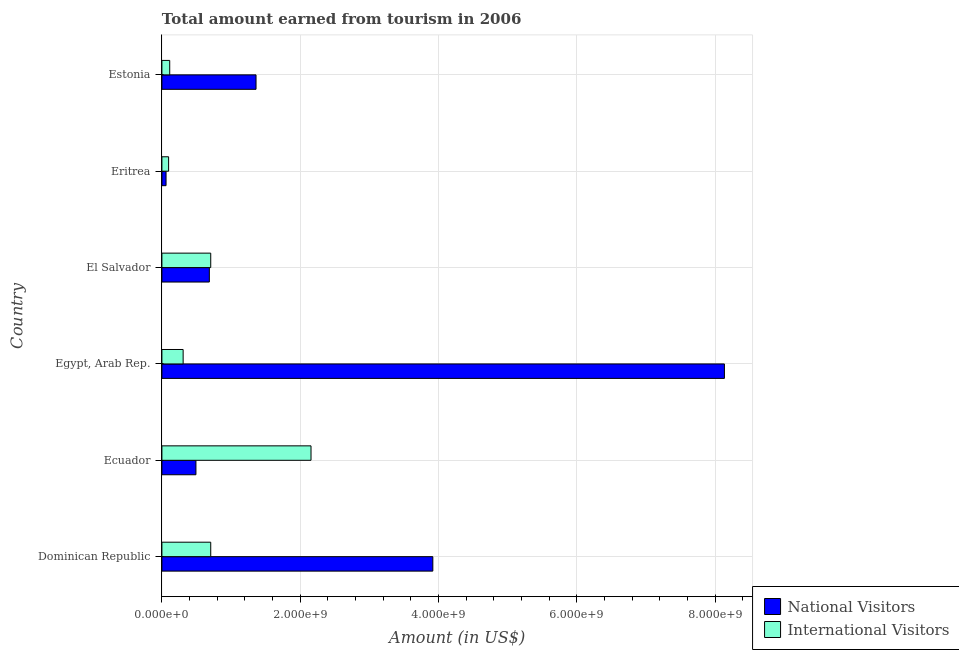Are the number of bars on each tick of the Y-axis equal?
Offer a very short reply. Yes. How many bars are there on the 3rd tick from the top?
Offer a very short reply. 2. What is the label of the 5th group of bars from the top?
Offer a very short reply. Ecuador. In how many cases, is the number of bars for a given country not equal to the number of legend labels?
Give a very brief answer. 0. What is the amount earned from international visitors in Ecuador?
Make the answer very short. 2.16e+09. Across all countries, what is the maximum amount earned from international visitors?
Your answer should be compact. 2.16e+09. Across all countries, what is the minimum amount earned from international visitors?
Offer a very short reply. 9.70e+07. In which country was the amount earned from international visitors maximum?
Give a very brief answer. Ecuador. In which country was the amount earned from national visitors minimum?
Your answer should be very brief. Eritrea. What is the total amount earned from international visitors in the graph?
Your answer should be very brief. 4.08e+09. What is the difference between the amount earned from international visitors in Ecuador and that in Egypt, Arab Rep.?
Provide a succinct answer. 1.85e+09. What is the difference between the amount earned from international visitors in Estonia and the amount earned from national visitors in El Salvador?
Keep it short and to the point. -5.73e+08. What is the average amount earned from international visitors per country?
Offer a very short reply. 6.81e+08. What is the difference between the amount earned from national visitors and amount earned from international visitors in El Salvador?
Your response must be concise. -2.00e+07. What is the ratio of the amount earned from national visitors in Eritrea to that in Estonia?
Your answer should be very brief. 0.04. Is the amount earned from international visitors in Dominican Republic less than that in Eritrea?
Provide a succinct answer. No. Is the difference between the amount earned from national visitors in Dominican Republic and Eritrea greater than the difference between the amount earned from international visitors in Dominican Republic and Eritrea?
Your answer should be very brief. Yes. What is the difference between the highest and the second highest amount earned from international visitors?
Provide a succinct answer. 1.45e+09. What is the difference between the highest and the lowest amount earned from national visitors?
Provide a succinct answer. 8.07e+09. In how many countries, is the amount earned from international visitors greater than the average amount earned from international visitors taken over all countries?
Keep it short and to the point. 3. Is the sum of the amount earned from national visitors in Egypt, Arab Rep. and El Salvador greater than the maximum amount earned from international visitors across all countries?
Offer a terse response. Yes. What does the 2nd bar from the top in Estonia represents?
Your response must be concise. National Visitors. What does the 2nd bar from the bottom in Eritrea represents?
Your response must be concise. International Visitors. Are all the bars in the graph horizontal?
Make the answer very short. Yes. What is the difference between two consecutive major ticks on the X-axis?
Provide a succinct answer. 2.00e+09. Are the values on the major ticks of X-axis written in scientific E-notation?
Make the answer very short. Yes. Where does the legend appear in the graph?
Keep it short and to the point. Bottom right. How are the legend labels stacked?
Your response must be concise. Vertical. What is the title of the graph?
Your answer should be very brief. Total amount earned from tourism in 2006. What is the label or title of the X-axis?
Provide a short and direct response. Amount (in US$). What is the label or title of the Y-axis?
Your answer should be very brief. Country. What is the Amount (in US$) in National Visitors in Dominican Republic?
Provide a succinct answer. 3.92e+09. What is the Amount (in US$) of International Visitors in Dominican Republic?
Provide a short and direct response. 7.06e+08. What is the Amount (in US$) in National Visitors in Ecuador?
Your answer should be compact. 4.92e+08. What is the Amount (in US$) in International Visitors in Ecuador?
Provide a succinct answer. 2.16e+09. What is the Amount (in US$) of National Visitors in Egypt, Arab Rep.?
Your response must be concise. 8.13e+09. What is the Amount (in US$) in International Visitors in Egypt, Arab Rep.?
Ensure brevity in your answer.  3.07e+08. What is the Amount (in US$) of National Visitors in El Salvador?
Offer a terse response. 6.86e+08. What is the Amount (in US$) in International Visitors in El Salvador?
Make the answer very short. 7.06e+08. What is the Amount (in US$) of National Visitors in Eritrea?
Your response must be concise. 6.00e+07. What is the Amount (in US$) of International Visitors in Eritrea?
Keep it short and to the point. 9.70e+07. What is the Amount (in US$) in National Visitors in Estonia?
Give a very brief answer. 1.36e+09. What is the Amount (in US$) of International Visitors in Estonia?
Your answer should be very brief. 1.13e+08. Across all countries, what is the maximum Amount (in US$) in National Visitors?
Provide a short and direct response. 8.13e+09. Across all countries, what is the maximum Amount (in US$) of International Visitors?
Your answer should be very brief. 2.16e+09. Across all countries, what is the minimum Amount (in US$) in National Visitors?
Provide a succinct answer. 6.00e+07. Across all countries, what is the minimum Amount (in US$) in International Visitors?
Your answer should be compact. 9.70e+07. What is the total Amount (in US$) of National Visitors in the graph?
Provide a short and direct response. 1.46e+1. What is the total Amount (in US$) of International Visitors in the graph?
Make the answer very short. 4.08e+09. What is the difference between the Amount (in US$) of National Visitors in Dominican Republic and that in Ecuador?
Your answer should be compact. 3.42e+09. What is the difference between the Amount (in US$) in International Visitors in Dominican Republic and that in Ecuador?
Your answer should be very brief. -1.45e+09. What is the difference between the Amount (in US$) of National Visitors in Dominican Republic and that in Egypt, Arab Rep.?
Keep it short and to the point. -4.22e+09. What is the difference between the Amount (in US$) of International Visitors in Dominican Republic and that in Egypt, Arab Rep.?
Your answer should be compact. 3.99e+08. What is the difference between the Amount (in US$) in National Visitors in Dominican Republic and that in El Salvador?
Give a very brief answer. 3.23e+09. What is the difference between the Amount (in US$) of International Visitors in Dominican Republic and that in El Salvador?
Offer a very short reply. 0. What is the difference between the Amount (in US$) of National Visitors in Dominican Republic and that in Eritrea?
Your answer should be compact. 3.86e+09. What is the difference between the Amount (in US$) in International Visitors in Dominican Republic and that in Eritrea?
Your response must be concise. 6.09e+08. What is the difference between the Amount (in US$) of National Visitors in Dominican Republic and that in Estonia?
Your answer should be compact. 2.56e+09. What is the difference between the Amount (in US$) in International Visitors in Dominican Republic and that in Estonia?
Make the answer very short. 5.93e+08. What is the difference between the Amount (in US$) of National Visitors in Ecuador and that in Egypt, Arab Rep.?
Keep it short and to the point. -7.64e+09. What is the difference between the Amount (in US$) in International Visitors in Ecuador and that in Egypt, Arab Rep.?
Your answer should be compact. 1.85e+09. What is the difference between the Amount (in US$) in National Visitors in Ecuador and that in El Salvador?
Give a very brief answer. -1.94e+08. What is the difference between the Amount (in US$) in International Visitors in Ecuador and that in El Salvador?
Offer a terse response. 1.45e+09. What is the difference between the Amount (in US$) of National Visitors in Ecuador and that in Eritrea?
Provide a succinct answer. 4.32e+08. What is the difference between the Amount (in US$) of International Visitors in Ecuador and that in Eritrea?
Offer a terse response. 2.06e+09. What is the difference between the Amount (in US$) in National Visitors in Ecuador and that in Estonia?
Your answer should be very brief. -8.69e+08. What is the difference between the Amount (in US$) of International Visitors in Ecuador and that in Estonia?
Offer a terse response. 2.04e+09. What is the difference between the Amount (in US$) in National Visitors in Egypt, Arab Rep. and that in El Salvador?
Provide a succinct answer. 7.45e+09. What is the difference between the Amount (in US$) of International Visitors in Egypt, Arab Rep. and that in El Salvador?
Ensure brevity in your answer.  -3.99e+08. What is the difference between the Amount (in US$) in National Visitors in Egypt, Arab Rep. and that in Eritrea?
Your answer should be very brief. 8.07e+09. What is the difference between the Amount (in US$) of International Visitors in Egypt, Arab Rep. and that in Eritrea?
Your answer should be very brief. 2.10e+08. What is the difference between the Amount (in US$) of National Visitors in Egypt, Arab Rep. and that in Estonia?
Ensure brevity in your answer.  6.77e+09. What is the difference between the Amount (in US$) in International Visitors in Egypt, Arab Rep. and that in Estonia?
Offer a terse response. 1.94e+08. What is the difference between the Amount (in US$) in National Visitors in El Salvador and that in Eritrea?
Keep it short and to the point. 6.26e+08. What is the difference between the Amount (in US$) of International Visitors in El Salvador and that in Eritrea?
Ensure brevity in your answer.  6.09e+08. What is the difference between the Amount (in US$) of National Visitors in El Salvador and that in Estonia?
Keep it short and to the point. -6.75e+08. What is the difference between the Amount (in US$) of International Visitors in El Salvador and that in Estonia?
Your answer should be very brief. 5.93e+08. What is the difference between the Amount (in US$) in National Visitors in Eritrea and that in Estonia?
Provide a succinct answer. -1.30e+09. What is the difference between the Amount (in US$) in International Visitors in Eritrea and that in Estonia?
Provide a succinct answer. -1.60e+07. What is the difference between the Amount (in US$) of National Visitors in Dominican Republic and the Amount (in US$) of International Visitors in Ecuador?
Offer a terse response. 1.76e+09. What is the difference between the Amount (in US$) in National Visitors in Dominican Republic and the Amount (in US$) in International Visitors in Egypt, Arab Rep.?
Your answer should be compact. 3.61e+09. What is the difference between the Amount (in US$) of National Visitors in Dominican Republic and the Amount (in US$) of International Visitors in El Salvador?
Offer a very short reply. 3.21e+09. What is the difference between the Amount (in US$) of National Visitors in Dominican Republic and the Amount (in US$) of International Visitors in Eritrea?
Make the answer very short. 3.82e+09. What is the difference between the Amount (in US$) of National Visitors in Dominican Republic and the Amount (in US$) of International Visitors in Estonia?
Make the answer very short. 3.80e+09. What is the difference between the Amount (in US$) in National Visitors in Ecuador and the Amount (in US$) in International Visitors in Egypt, Arab Rep.?
Provide a succinct answer. 1.85e+08. What is the difference between the Amount (in US$) in National Visitors in Ecuador and the Amount (in US$) in International Visitors in El Salvador?
Offer a very short reply. -2.14e+08. What is the difference between the Amount (in US$) in National Visitors in Ecuador and the Amount (in US$) in International Visitors in Eritrea?
Make the answer very short. 3.95e+08. What is the difference between the Amount (in US$) in National Visitors in Ecuador and the Amount (in US$) in International Visitors in Estonia?
Give a very brief answer. 3.79e+08. What is the difference between the Amount (in US$) in National Visitors in Egypt, Arab Rep. and the Amount (in US$) in International Visitors in El Salvador?
Your answer should be compact. 7.43e+09. What is the difference between the Amount (in US$) in National Visitors in Egypt, Arab Rep. and the Amount (in US$) in International Visitors in Eritrea?
Your answer should be compact. 8.04e+09. What is the difference between the Amount (in US$) of National Visitors in Egypt, Arab Rep. and the Amount (in US$) of International Visitors in Estonia?
Your answer should be compact. 8.02e+09. What is the difference between the Amount (in US$) in National Visitors in El Salvador and the Amount (in US$) in International Visitors in Eritrea?
Keep it short and to the point. 5.89e+08. What is the difference between the Amount (in US$) of National Visitors in El Salvador and the Amount (in US$) of International Visitors in Estonia?
Provide a short and direct response. 5.73e+08. What is the difference between the Amount (in US$) in National Visitors in Eritrea and the Amount (in US$) in International Visitors in Estonia?
Keep it short and to the point. -5.30e+07. What is the average Amount (in US$) in National Visitors per country?
Provide a short and direct response. 2.44e+09. What is the average Amount (in US$) of International Visitors per country?
Provide a succinct answer. 6.81e+08. What is the difference between the Amount (in US$) in National Visitors and Amount (in US$) in International Visitors in Dominican Republic?
Offer a very short reply. 3.21e+09. What is the difference between the Amount (in US$) of National Visitors and Amount (in US$) of International Visitors in Ecuador?
Give a very brief answer. -1.66e+09. What is the difference between the Amount (in US$) in National Visitors and Amount (in US$) in International Visitors in Egypt, Arab Rep.?
Provide a short and direct response. 7.83e+09. What is the difference between the Amount (in US$) in National Visitors and Amount (in US$) in International Visitors in El Salvador?
Keep it short and to the point. -2.00e+07. What is the difference between the Amount (in US$) in National Visitors and Amount (in US$) in International Visitors in Eritrea?
Offer a very short reply. -3.70e+07. What is the difference between the Amount (in US$) of National Visitors and Amount (in US$) of International Visitors in Estonia?
Your answer should be very brief. 1.25e+09. What is the ratio of the Amount (in US$) of National Visitors in Dominican Republic to that in Ecuador?
Give a very brief answer. 7.96. What is the ratio of the Amount (in US$) in International Visitors in Dominican Republic to that in Ecuador?
Your answer should be compact. 0.33. What is the ratio of the Amount (in US$) of National Visitors in Dominican Republic to that in Egypt, Arab Rep.?
Your response must be concise. 0.48. What is the ratio of the Amount (in US$) in International Visitors in Dominican Republic to that in Egypt, Arab Rep.?
Make the answer very short. 2.3. What is the ratio of the Amount (in US$) of National Visitors in Dominican Republic to that in El Salvador?
Offer a very short reply. 5.71. What is the ratio of the Amount (in US$) of National Visitors in Dominican Republic to that in Eritrea?
Give a very brief answer. 65.28. What is the ratio of the Amount (in US$) of International Visitors in Dominican Republic to that in Eritrea?
Ensure brevity in your answer.  7.28. What is the ratio of the Amount (in US$) in National Visitors in Dominican Republic to that in Estonia?
Offer a terse response. 2.88. What is the ratio of the Amount (in US$) in International Visitors in Dominican Republic to that in Estonia?
Make the answer very short. 6.25. What is the ratio of the Amount (in US$) of National Visitors in Ecuador to that in Egypt, Arab Rep.?
Keep it short and to the point. 0.06. What is the ratio of the Amount (in US$) of International Visitors in Ecuador to that in Egypt, Arab Rep.?
Your answer should be compact. 7.02. What is the ratio of the Amount (in US$) in National Visitors in Ecuador to that in El Salvador?
Your answer should be compact. 0.72. What is the ratio of the Amount (in US$) in International Visitors in Ecuador to that in El Salvador?
Provide a short and direct response. 3.05. What is the ratio of the Amount (in US$) of National Visitors in Ecuador to that in Eritrea?
Your answer should be very brief. 8.2. What is the ratio of the Amount (in US$) in International Visitors in Ecuador to that in Eritrea?
Give a very brief answer. 22.23. What is the ratio of the Amount (in US$) of National Visitors in Ecuador to that in Estonia?
Offer a terse response. 0.36. What is the ratio of the Amount (in US$) of International Visitors in Ecuador to that in Estonia?
Give a very brief answer. 19.08. What is the ratio of the Amount (in US$) in National Visitors in Egypt, Arab Rep. to that in El Salvador?
Offer a terse response. 11.86. What is the ratio of the Amount (in US$) of International Visitors in Egypt, Arab Rep. to that in El Salvador?
Provide a short and direct response. 0.43. What is the ratio of the Amount (in US$) of National Visitors in Egypt, Arab Rep. to that in Eritrea?
Your answer should be very brief. 135.55. What is the ratio of the Amount (in US$) of International Visitors in Egypt, Arab Rep. to that in Eritrea?
Your answer should be very brief. 3.16. What is the ratio of the Amount (in US$) of National Visitors in Egypt, Arab Rep. to that in Estonia?
Give a very brief answer. 5.98. What is the ratio of the Amount (in US$) in International Visitors in Egypt, Arab Rep. to that in Estonia?
Your answer should be compact. 2.72. What is the ratio of the Amount (in US$) in National Visitors in El Salvador to that in Eritrea?
Your response must be concise. 11.43. What is the ratio of the Amount (in US$) of International Visitors in El Salvador to that in Eritrea?
Make the answer very short. 7.28. What is the ratio of the Amount (in US$) of National Visitors in El Salvador to that in Estonia?
Give a very brief answer. 0.5. What is the ratio of the Amount (in US$) of International Visitors in El Salvador to that in Estonia?
Provide a short and direct response. 6.25. What is the ratio of the Amount (in US$) of National Visitors in Eritrea to that in Estonia?
Keep it short and to the point. 0.04. What is the ratio of the Amount (in US$) in International Visitors in Eritrea to that in Estonia?
Give a very brief answer. 0.86. What is the difference between the highest and the second highest Amount (in US$) of National Visitors?
Give a very brief answer. 4.22e+09. What is the difference between the highest and the second highest Amount (in US$) of International Visitors?
Make the answer very short. 1.45e+09. What is the difference between the highest and the lowest Amount (in US$) of National Visitors?
Make the answer very short. 8.07e+09. What is the difference between the highest and the lowest Amount (in US$) of International Visitors?
Provide a succinct answer. 2.06e+09. 